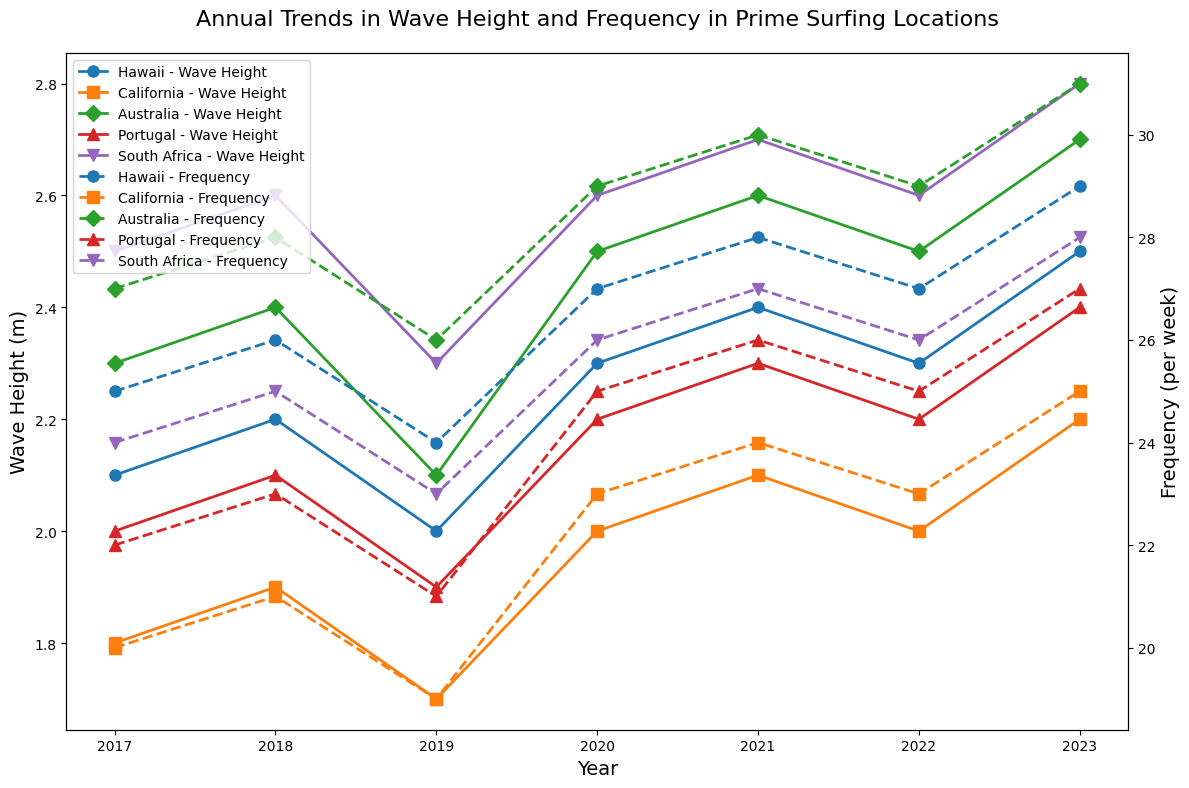What's the highest wave height observed for Hawaii and in which year? The blue line with 'o' markers represents Hawaii. The highest point on this line is at 2.5 meters in the year 2023.
Answer: 2.5 meters in 2023 Which location had the highest frequency of waves per week in 2023? Look for the endpoints of all the dashed lines in 2023 and compare their values. The purple dashed line with 'v' markers (South Africa) reaches the highest frequency at 28 waves per week.
Answer: South Africa Between 2019 and 2023, which location saw the most significant increase in wave height? Compare the start and end points of the solid lines from 2019 to 2023 for each location. Hawaii (blue), California (orange), Australia (green), Portugal (red), and South Africa (purple) show increases, with Australia's increase from 2.1 meters to 2.7 meters being the highest (0.6 meters).
Answer: Australia By how much did the frequency of waves per week for Portugal increase from 2017 to 2023? The red dashed line with '^' markers shows Portugal's frequency: 22 waves per week in 2017 and 27 waves per week in 2023. The increase is calculated as 27 - 22 = 5.
Answer: 5 What's the average wave height for Australia from 2017 to 2023? Sum up the green line values between 2017 and 2023: 2.3, 2.4, 2.1, 2.5, 2.6, 2.5, 2.7. The total is 17.1. There are 7 years, so the average is 17.1 / 7 = 2.44 meters.
Answer: 2.44 meters Which two locations had equal wave heights in any given year, and which year was it? Check each year for matching solid lines. In 2020, both Hawaii (blue with 'o' markers) and South Africa (purple with 'v' markers) had a wave height of 2.6 meters.
Answer: Hawaii and South Africa in 2020 Which location had the most steady wave height trend from 2017 to 2023? Look for the least fluctuation in the solid lines. California's orange line with 's' markers has the least apparent fluctuation around the mean value over the years.
Answer: California 